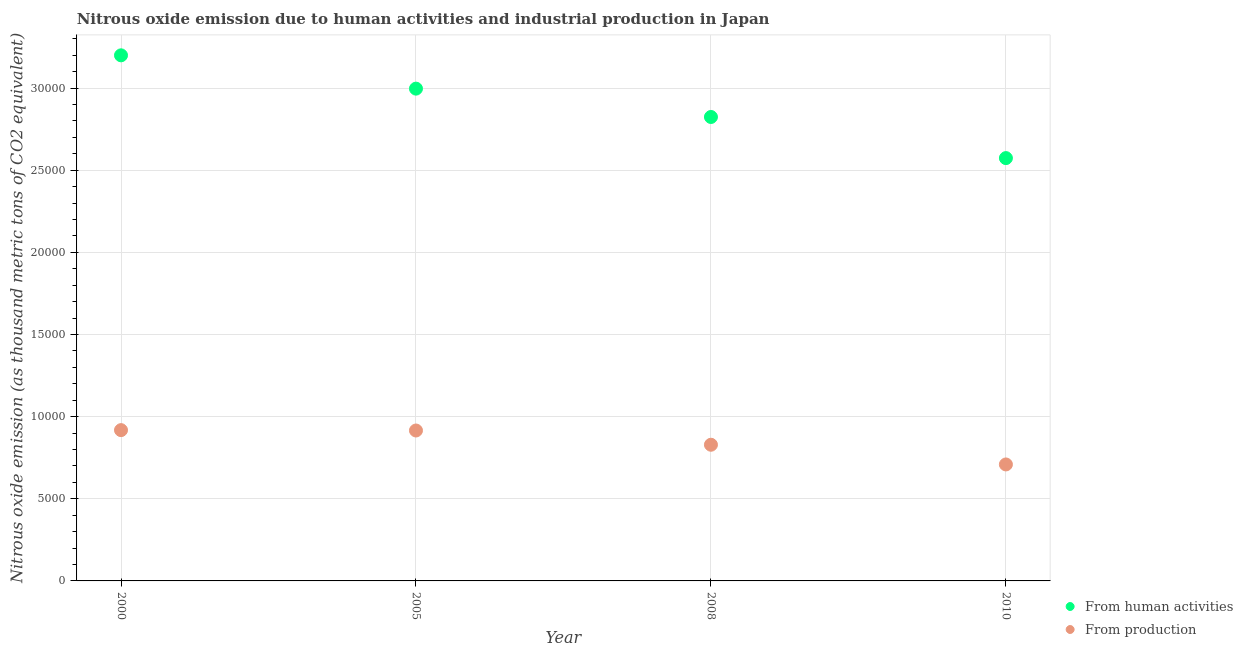How many different coloured dotlines are there?
Your answer should be compact. 2. Is the number of dotlines equal to the number of legend labels?
Make the answer very short. Yes. What is the amount of emissions generated from industries in 2005?
Offer a terse response. 9157. Across all years, what is the maximum amount of emissions generated from industries?
Give a very brief answer. 9179.4. Across all years, what is the minimum amount of emissions generated from industries?
Provide a succinct answer. 7090.6. In which year was the amount of emissions generated from industries maximum?
Make the answer very short. 2000. What is the total amount of emissions generated from industries in the graph?
Offer a very short reply. 3.37e+04. What is the difference between the amount of emissions generated from industries in 2000 and that in 2008?
Make the answer very short. 889.4. What is the difference between the amount of emissions from human activities in 2008 and the amount of emissions generated from industries in 2005?
Provide a short and direct response. 1.91e+04. What is the average amount of emissions generated from industries per year?
Give a very brief answer. 8429.25. In the year 2005, what is the difference between the amount of emissions generated from industries and amount of emissions from human activities?
Provide a short and direct response. -2.08e+04. In how many years, is the amount of emissions from human activities greater than 2000 thousand metric tons?
Offer a very short reply. 4. What is the ratio of the amount of emissions from human activities in 2000 to that in 2010?
Offer a very short reply. 1.24. Is the amount of emissions from human activities in 2005 less than that in 2008?
Make the answer very short. No. What is the difference between the highest and the second highest amount of emissions from human activities?
Your response must be concise. 2027.5. What is the difference between the highest and the lowest amount of emissions from human activities?
Offer a terse response. 6256.2. Is the sum of the amount of emissions generated from industries in 2005 and 2010 greater than the maximum amount of emissions from human activities across all years?
Ensure brevity in your answer.  No. Is the amount of emissions from human activities strictly less than the amount of emissions generated from industries over the years?
Your response must be concise. No. How many dotlines are there?
Offer a terse response. 2. How many years are there in the graph?
Give a very brief answer. 4. Are the values on the major ticks of Y-axis written in scientific E-notation?
Make the answer very short. No. What is the title of the graph?
Your response must be concise. Nitrous oxide emission due to human activities and industrial production in Japan. Does "RDB nonconcessional" appear as one of the legend labels in the graph?
Offer a terse response. No. What is the label or title of the X-axis?
Your response must be concise. Year. What is the label or title of the Y-axis?
Provide a short and direct response. Nitrous oxide emission (as thousand metric tons of CO2 equivalent). What is the Nitrous oxide emission (as thousand metric tons of CO2 equivalent) in From human activities in 2000?
Make the answer very short. 3.20e+04. What is the Nitrous oxide emission (as thousand metric tons of CO2 equivalent) of From production in 2000?
Your response must be concise. 9179.4. What is the Nitrous oxide emission (as thousand metric tons of CO2 equivalent) in From human activities in 2005?
Offer a very short reply. 3.00e+04. What is the Nitrous oxide emission (as thousand metric tons of CO2 equivalent) in From production in 2005?
Your response must be concise. 9157. What is the Nitrous oxide emission (as thousand metric tons of CO2 equivalent) in From human activities in 2008?
Give a very brief answer. 2.82e+04. What is the Nitrous oxide emission (as thousand metric tons of CO2 equivalent) of From production in 2008?
Give a very brief answer. 8290. What is the Nitrous oxide emission (as thousand metric tons of CO2 equivalent) of From human activities in 2010?
Give a very brief answer. 2.57e+04. What is the Nitrous oxide emission (as thousand metric tons of CO2 equivalent) in From production in 2010?
Offer a very short reply. 7090.6. Across all years, what is the maximum Nitrous oxide emission (as thousand metric tons of CO2 equivalent) of From human activities?
Give a very brief answer. 3.20e+04. Across all years, what is the maximum Nitrous oxide emission (as thousand metric tons of CO2 equivalent) of From production?
Offer a terse response. 9179.4. Across all years, what is the minimum Nitrous oxide emission (as thousand metric tons of CO2 equivalent) of From human activities?
Make the answer very short. 2.57e+04. Across all years, what is the minimum Nitrous oxide emission (as thousand metric tons of CO2 equivalent) of From production?
Your response must be concise. 7090.6. What is the total Nitrous oxide emission (as thousand metric tons of CO2 equivalent) in From human activities in the graph?
Your response must be concise. 1.16e+05. What is the total Nitrous oxide emission (as thousand metric tons of CO2 equivalent) of From production in the graph?
Your answer should be compact. 3.37e+04. What is the difference between the Nitrous oxide emission (as thousand metric tons of CO2 equivalent) in From human activities in 2000 and that in 2005?
Give a very brief answer. 2027.5. What is the difference between the Nitrous oxide emission (as thousand metric tons of CO2 equivalent) of From production in 2000 and that in 2005?
Your answer should be very brief. 22.4. What is the difference between the Nitrous oxide emission (as thousand metric tons of CO2 equivalent) of From human activities in 2000 and that in 2008?
Make the answer very short. 3753.1. What is the difference between the Nitrous oxide emission (as thousand metric tons of CO2 equivalent) in From production in 2000 and that in 2008?
Your answer should be very brief. 889.4. What is the difference between the Nitrous oxide emission (as thousand metric tons of CO2 equivalent) of From human activities in 2000 and that in 2010?
Make the answer very short. 6256.2. What is the difference between the Nitrous oxide emission (as thousand metric tons of CO2 equivalent) in From production in 2000 and that in 2010?
Your response must be concise. 2088.8. What is the difference between the Nitrous oxide emission (as thousand metric tons of CO2 equivalent) of From human activities in 2005 and that in 2008?
Make the answer very short. 1725.6. What is the difference between the Nitrous oxide emission (as thousand metric tons of CO2 equivalent) of From production in 2005 and that in 2008?
Ensure brevity in your answer.  867. What is the difference between the Nitrous oxide emission (as thousand metric tons of CO2 equivalent) of From human activities in 2005 and that in 2010?
Your answer should be very brief. 4228.7. What is the difference between the Nitrous oxide emission (as thousand metric tons of CO2 equivalent) in From production in 2005 and that in 2010?
Give a very brief answer. 2066.4. What is the difference between the Nitrous oxide emission (as thousand metric tons of CO2 equivalent) in From human activities in 2008 and that in 2010?
Make the answer very short. 2503.1. What is the difference between the Nitrous oxide emission (as thousand metric tons of CO2 equivalent) in From production in 2008 and that in 2010?
Give a very brief answer. 1199.4. What is the difference between the Nitrous oxide emission (as thousand metric tons of CO2 equivalent) in From human activities in 2000 and the Nitrous oxide emission (as thousand metric tons of CO2 equivalent) in From production in 2005?
Your response must be concise. 2.28e+04. What is the difference between the Nitrous oxide emission (as thousand metric tons of CO2 equivalent) of From human activities in 2000 and the Nitrous oxide emission (as thousand metric tons of CO2 equivalent) of From production in 2008?
Make the answer very short. 2.37e+04. What is the difference between the Nitrous oxide emission (as thousand metric tons of CO2 equivalent) in From human activities in 2000 and the Nitrous oxide emission (as thousand metric tons of CO2 equivalent) in From production in 2010?
Provide a succinct answer. 2.49e+04. What is the difference between the Nitrous oxide emission (as thousand metric tons of CO2 equivalent) of From human activities in 2005 and the Nitrous oxide emission (as thousand metric tons of CO2 equivalent) of From production in 2008?
Your answer should be very brief. 2.17e+04. What is the difference between the Nitrous oxide emission (as thousand metric tons of CO2 equivalent) of From human activities in 2005 and the Nitrous oxide emission (as thousand metric tons of CO2 equivalent) of From production in 2010?
Offer a terse response. 2.29e+04. What is the difference between the Nitrous oxide emission (as thousand metric tons of CO2 equivalent) in From human activities in 2008 and the Nitrous oxide emission (as thousand metric tons of CO2 equivalent) in From production in 2010?
Give a very brief answer. 2.12e+04. What is the average Nitrous oxide emission (as thousand metric tons of CO2 equivalent) in From human activities per year?
Your response must be concise. 2.90e+04. What is the average Nitrous oxide emission (as thousand metric tons of CO2 equivalent) in From production per year?
Ensure brevity in your answer.  8429.25. In the year 2000, what is the difference between the Nitrous oxide emission (as thousand metric tons of CO2 equivalent) in From human activities and Nitrous oxide emission (as thousand metric tons of CO2 equivalent) in From production?
Your answer should be compact. 2.28e+04. In the year 2005, what is the difference between the Nitrous oxide emission (as thousand metric tons of CO2 equivalent) of From human activities and Nitrous oxide emission (as thousand metric tons of CO2 equivalent) of From production?
Offer a very short reply. 2.08e+04. In the year 2008, what is the difference between the Nitrous oxide emission (as thousand metric tons of CO2 equivalent) in From human activities and Nitrous oxide emission (as thousand metric tons of CO2 equivalent) in From production?
Provide a short and direct response. 2.00e+04. In the year 2010, what is the difference between the Nitrous oxide emission (as thousand metric tons of CO2 equivalent) in From human activities and Nitrous oxide emission (as thousand metric tons of CO2 equivalent) in From production?
Offer a very short reply. 1.86e+04. What is the ratio of the Nitrous oxide emission (as thousand metric tons of CO2 equivalent) of From human activities in 2000 to that in 2005?
Ensure brevity in your answer.  1.07. What is the ratio of the Nitrous oxide emission (as thousand metric tons of CO2 equivalent) of From human activities in 2000 to that in 2008?
Offer a terse response. 1.13. What is the ratio of the Nitrous oxide emission (as thousand metric tons of CO2 equivalent) of From production in 2000 to that in 2008?
Give a very brief answer. 1.11. What is the ratio of the Nitrous oxide emission (as thousand metric tons of CO2 equivalent) of From human activities in 2000 to that in 2010?
Ensure brevity in your answer.  1.24. What is the ratio of the Nitrous oxide emission (as thousand metric tons of CO2 equivalent) in From production in 2000 to that in 2010?
Provide a succinct answer. 1.29. What is the ratio of the Nitrous oxide emission (as thousand metric tons of CO2 equivalent) in From human activities in 2005 to that in 2008?
Ensure brevity in your answer.  1.06. What is the ratio of the Nitrous oxide emission (as thousand metric tons of CO2 equivalent) of From production in 2005 to that in 2008?
Your response must be concise. 1.1. What is the ratio of the Nitrous oxide emission (as thousand metric tons of CO2 equivalent) in From human activities in 2005 to that in 2010?
Provide a succinct answer. 1.16. What is the ratio of the Nitrous oxide emission (as thousand metric tons of CO2 equivalent) of From production in 2005 to that in 2010?
Offer a very short reply. 1.29. What is the ratio of the Nitrous oxide emission (as thousand metric tons of CO2 equivalent) of From human activities in 2008 to that in 2010?
Provide a succinct answer. 1.1. What is the ratio of the Nitrous oxide emission (as thousand metric tons of CO2 equivalent) of From production in 2008 to that in 2010?
Give a very brief answer. 1.17. What is the difference between the highest and the second highest Nitrous oxide emission (as thousand metric tons of CO2 equivalent) in From human activities?
Your answer should be very brief. 2027.5. What is the difference between the highest and the second highest Nitrous oxide emission (as thousand metric tons of CO2 equivalent) in From production?
Keep it short and to the point. 22.4. What is the difference between the highest and the lowest Nitrous oxide emission (as thousand metric tons of CO2 equivalent) in From human activities?
Your answer should be very brief. 6256.2. What is the difference between the highest and the lowest Nitrous oxide emission (as thousand metric tons of CO2 equivalent) in From production?
Offer a very short reply. 2088.8. 